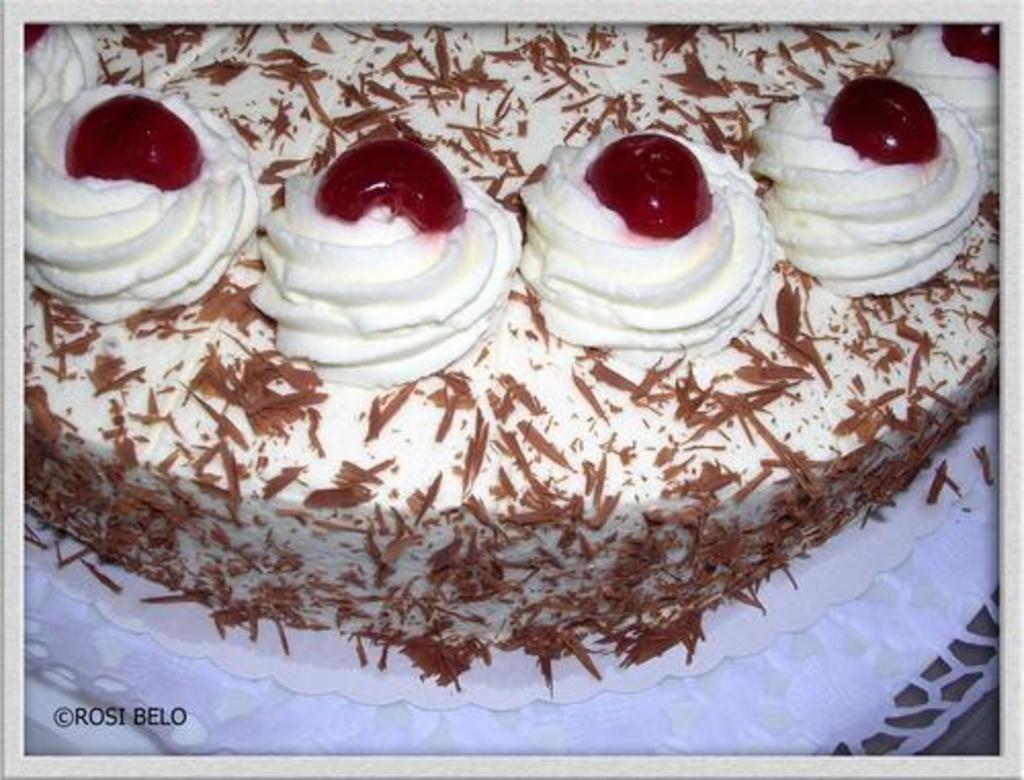Describe this image in one or two sentences. In this image I can see the cake and the cake is in white, brown and red color. 